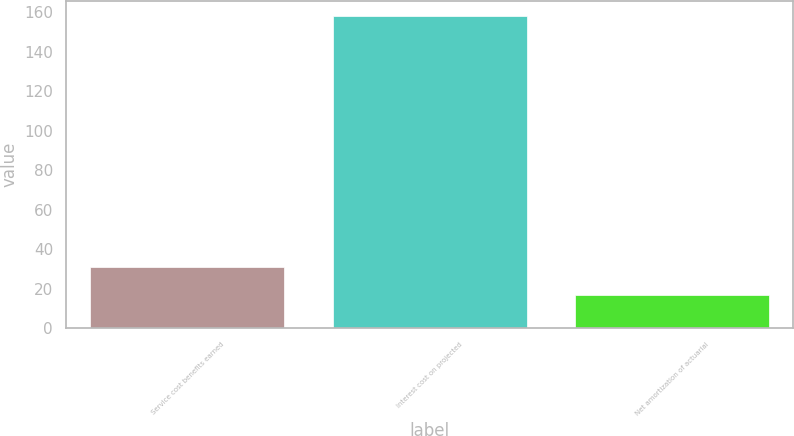Convert chart. <chart><loc_0><loc_0><loc_500><loc_500><bar_chart><fcel>Service cost benefits earned<fcel>Interest cost on projected<fcel>Net amortization of actuarial<nl><fcel>31.1<fcel>158<fcel>17<nl></chart> 